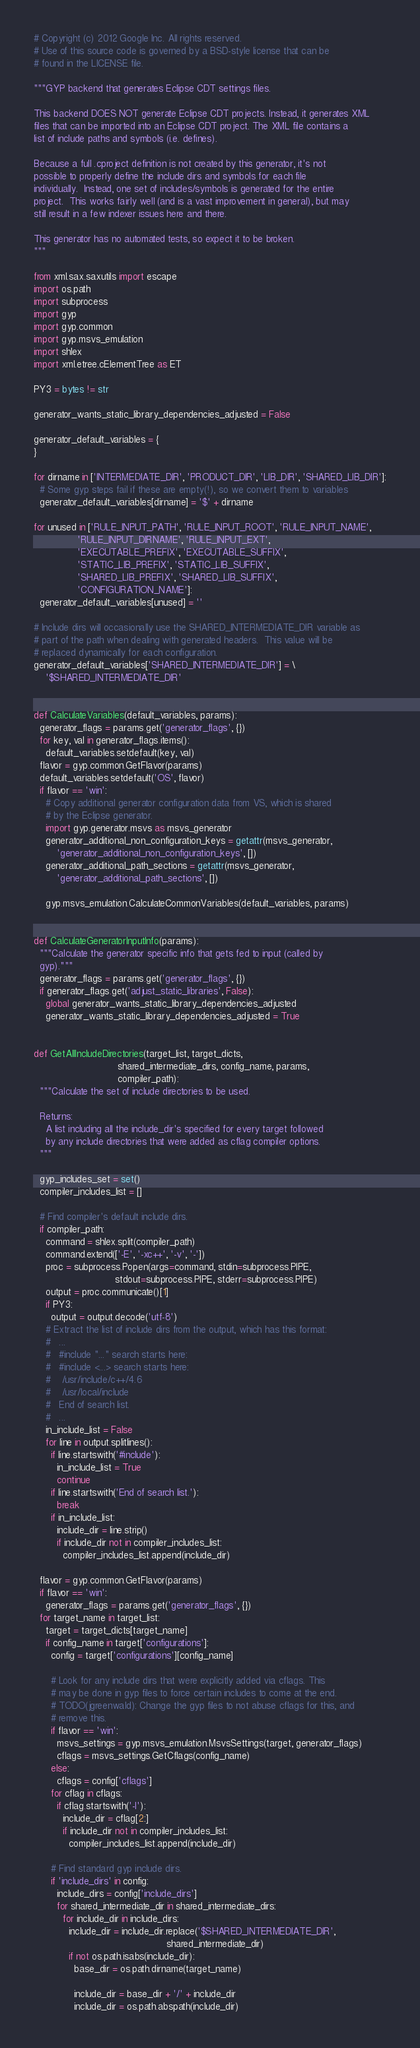Convert code to text. <code><loc_0><loc_0><loc_500><loc_500><_Python_># Copyright (c) 2012 Google Inc. All rights reserved.
# Use of this source code is governed by a BSD-style license that can be
# found in the LICENSE file.

"""GYP backend that generates Eclipse CDT settings files.

This backend DOES NOT generate Eclipse CDT projects. Instead, it generates XML
files that can be imported into an Eclipse CDT project. The XML file contains a
list of include paths and symbols (i.e. defines).

Because a full .cproject definition is not created by this generator, it's not
possible to properly define the include dirs and symbols for each file
individually.  Instead, one set of includes/symbols is generated for the entire
project.  This works fairly well (and is a vast improvement in general), but may
still result in a few indexer issues here and there.

This generator has no automated tests, so expect it to be broken.
"""

from xml.sax.saxutils import escape
import os.path
import subprocess
import gyp
import gyp.common
import gyp.msvs_emulation
import shlex
import xml.etree.cElementTree as ET

PY3 = bytes != str

generator_wants_static_library_dependencies_adjusted = False

generator_default_variables = {
}

for dirname in ['INTERMEDIATE_DIR', 'PRODUCT_DIR', 'LIB_DIR', 'SHARED_LIB_DIR']:
  # Some gyp steps fail if these are empty(!), so we convert them to variables
  generator_default_variables[dirname] = '$' + dirname

for unused in ['RULE_INPUT_PATH', 'RULE_INPUT_ROOT', 'RULE_INPUT_NAME',
               'RULE_INPUT_DIRNAME', 'RULE_INPUT_EXT',
               'EXECUTABLE_PREFIX', 'EXECUTABLE_SUFFIX',
               'STATIC_LIB_PREFIX', 'STATIC_LIB_SUFFIX',
               'SHARED_LIB_PREFIX', 'SHARED_LIB_SUFFIX',
               'CONFIGURATION_NAME']:
  generator_default_variables[unused] = ''

# Include dirs will occasionally use the SHARED_INTERMEDIATE_DIR variable as
# part of the path when dealing with generated headers.  This value will be
# replaced dynamically for each configuration.
generator_default_variables['SHARED_INTERMEDIATE_DIR'] = \
    '$SHARED_INTERMEDIATE_DIR'


def CalculateVariables(default_variables, params):
  generator_flags = params.get('generator_flags', {})
  for key, val in generator_flags.items():
    default_variables.setdefault(key, val)
  flavor = gyp.common.GetFlavor(params)
  default_variables.setdefault('OS', flavor)
  if flavor == 'win':
    # Copy additional generator configuration data from VS, which is shared
    # by the Eclipse generator.
    import gyp.generator.msvs as msvs_generator
    generator_additional_non_configuration_keys = getattr(msvs_generator,
        'generator_additional_non_configuration_keys', [])
    generator_additional_path_sections = getattr(msvs_generator,
        'generator_additional_path_sections', [])

    gyp.msvs_emulation.CalculateCommonVariables(default_variables, params)


def CalculateGeneratorInputInfo(params):
  """Calculate the generator specific info that gets fed to input (called by
  gyp)."""
  generator_flags = params.get('generator_flags', {})
  if generator_flags.get('adjust_static_libraries', False):
    global generator_wants_static_library_dependencies_adjusted
    generator_wants_static_library_dependencies_adjusted = True


def GetAllIncludeDirectories(target_list, target_dicts,
                             shared_intermediate_dirs, config_name, params,
                             compiler_path):
  """Calculate the set of include directories to be used.

  Returns:
    A list including all the include_dir's specified for every target followed
    by any include directories that were added as cflag compiler options.
  """

  gyp_includes_set = set()
  compiler_includes_list = []

  # Find compiler's default include dirs.
  if compiler_path:
    command = shlex.split(compiler_path)
    command.extend(['-E', '-xc++', '-v', '-'])
    proc = subprocess.Popen(args=command, stdin=subprocess.PIPE,
                            stdout=subprocess.PIPE, stderr=subprocess.PIPE)
    output = proc.communicate()[1]
    if PY3:
      output = output.decode('utf-8')
    # Extract the list of include dirs from the output, which has this format:
    #   ...
    #   #include "..." search starts here:
    #   #include <...> search starts here:
    #    /usr/include/c++/4.6
    #    /usr/local/include
    #   End of search list.
    #   ...
    in_include_list = False
    for line in output.splitlines():
      if line.startswith('#include'):
        in_include_list = True
        continue
      if line.startswith('End of search list.'):
        break
      if in_include_list:
        include_dir = line.strip()
        if include_dir not in compiler_includes_list:
          compiler_includes_list.append(include_dir)

  flavor = gyp.common.GetFlavor(params)
  if flavor == 'win':
    generator_flags = params.get('generator_flags', {})
  for target_name in target_list:
    target = target_dicts[target_name]
    if config_name in target['configurations']:
      config = target['configurations'][config_name]

      # Look for any include dirs that were explicitly added via cflags. This
      # may be done in gyp files to force certain includes to come at the end.
      # TODO(jgreenwald): Change the gyp files to not abuse cflags for this, and
      # remove this.
      if flavor == 'win':
        msvs_settings = gyp.msvs_emulation.MsvsSettings(target, generator_flags)
        cflags = msvs_settings.GetCflags(config_name)
      else:
        cflags = config['cflags']
      for cflag in cflags:
        if cflag.startswith('-I'):
          include_dir = cflag[2:]
          if include_dir not in compiler_includes_list:
            compiler_includes_list.append(include_dir)

      # Find standard gyp include dirs.
      if 'include_dirs' in config:
        include_dirs = config['include_dirs']
        for shared_intermediate_dir in shared_intermediate_dirs:
          for include_dir in include_dirs:
            include_dir = include_dir.replace('$SHARED_INTERMEDIATE_DIR',
                                              shared_intermediate_dir)
            if not os.path.isabs(include_dir):
              base_dir = os.path.dirname(target_name)

              include_dir = base_dir + '/' + include_dir
              include_dir = os.path.abspath(include_dir)
</code> 